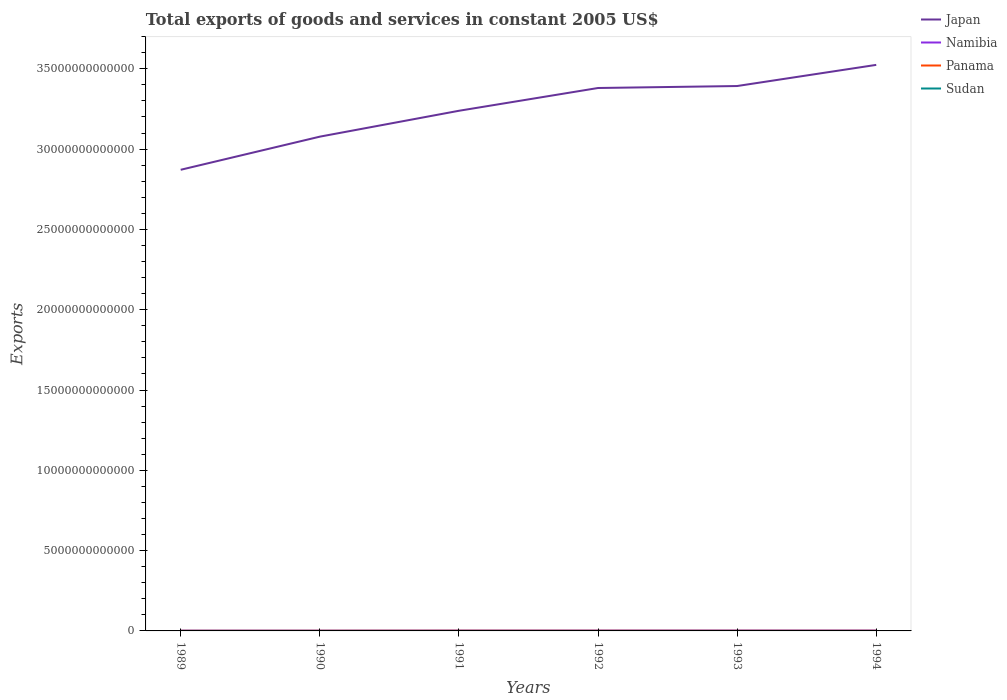Does the line corresponding to Namibia intersect with the line corresponding to Sudan?
Your response must be concise. No. Across all years, what is the maximum total exports of goods and services in Japan?
Give a very brief answer. 2.87e+13. In which year was the total exports of goods and services in Panama maximum?
Your answer should be very brief. 1989. What is the total total exports of goods and services in Sudan in the graph?
Offer a terse response. -1.11e+08. What is the difference between the highest and the second highest total exports of goods and services in Panama?
Offer a terse response. 4.54e+09. Is the total exports of goods and services in Namibia strictly greater than the total exports of goods and services in Panama over the years?
Offer a very short reply. No. How many lines are there?
Keep it short and to the point. 4. How many years are there in the graph?
Ensure brevity in your answer.  6. What is the difference between two consecutive major ticks on the Y-axis?
Make the answer very short. 5.00e+12. How many legend labels are there?
Provide a short and direct response. 4. What is the title of the graph?
Your answer should be compact. Total exports of goods and services in constant 2005 US$. What is the label or title of the X-axis?
Offer a very short reply. Years. What is the label or title of the Y-axis?
Make the answer very short. Exports. What is the Exports in Japan in 1989?
Provide a succinct answer. 2.87e+13. What is the Exports of Namibia in 1989?
Give a very brief answer. 1.60e+1. What is the Exports in Panama in 1989?
Keep it short and to the point. 7.19e+09. What is the Exports of Sudan in 1989?
Offer a terse response. 7.17e+08. What is the Exports in Japan in 1990?
Provide a short and direct response. 3.08e+13. What is the Exports of Namibia in 1990?
Provide a succinct answer. 1.42e+1. What is the Exports in Panama in 1990?
Your response must be concise. 8.42e+09. What is the Exports in Sudan in 1990?
Your answer should be very brief. 5.49e+08. What is the Exports in Japan in 1991?
Make the answer very short. 3.24e+13. What is the Exports in Namibia in 1991?
Give a very brief answer. 1.83e+1. What is the Exports in Panama in 1991?
Ensure brevity in your answer.  1.17e+1. What is the Exports in Sudan in 1991?
Make the answer very short. 5.02e+08. What is the Exports in Japan in 1992?
Ensure brevity in your answer.  3.38e+13. What is the Exports in Namibia in 1992?
Offer a terse response. 1.95e+1. What is the Exports of Panama in 1992?
Ensure brevity in your answer.  1.07e+1. What is the Exports in Sudan in 1992?
Offer a terse response. 6.14e+08. What is the Exports in Japan in 1993?
Provide a short and direct response. 3.39e+13. What is the Exports in Namibia in 1993?
Your answer should be very brief. 2.15e+1. What is the Exports in Panama in 1993?
Keep it short and to the point. 9.63e+09. What is the Exports in Sudan in 1993?
Your answer should be very brief. 5.62e+08. What is the Exports in Japan in 1994?
Your answer should be very brief. 3.52e+13. What is the Exports in Namibia in 1994?
Keep it short and to the point. 2.09e+1. What is the Exports of Panama in 1994?
Give a very brief answer. 9.27e+09. What is the Exports in Sudan in 1994?
Offer a terse response. 6.09e+08. Across all years, what is the maximum Exports in Japan?
Give a very brief answer. 3.52e+13. Across all years, what is the maximum Exports in Namibia?
Provide a short and direct response. 2.15e+1. Across all years, what is the maximum Exports in Panama?
Keep it short and to the point. 1.17e+1. Across all years, what is the maximum Exports in Sudan?
Give a very brief answer. 7.17e+08. Across all years, what is the minimum Exports of Japan?
Offer a very short reply. 2.87e+13. Across all years, what is the minimum Exports in Namibia?
Ensure brevity in your answer.  1.42e+1. Across all years, what is the minimum Exports in Panama?
Offer a terse response. 7.19e+09. Across all years, what is the minimum Exports in Sudan?
Keep it short and to the point. 5.02e+08. What is the total Exports in Japan in the graph?
Provide a succinct answer. 1.95e+14. What is the total Exports of Namibia in the graph?
Keep it short and to the point. 1.10e+11. What is the total Exports of Panama in the graph?
Keep it short and to the point. 5.70e+1. What is the total Exports of Sudan in the graph?
Keep it short and to the point. 3.55e+09. What is the difference between the Exports in Japan in 1989 and that in 1990?
Offer a terse response. -2.06e+12. What is the difference between the Exports of Namibia in 1989 and that in 1990?
Your response must be concise. 1.76e+09. What is the difference between the Exports in Panama in 1989 and that in 1990?
Offer a terse response. -1.23e+09. What is the difference between the Exports of Sudan in 1989 and that in 1990?
Your answer should be very brief. 1.69e+08. What is the difference between the Exports of Japan in 1989 and that in 1991?
Make the answer very short. -3.67e+12. What is the difference between the Exports in Namibia in 1989 and that in 1991?
Provide a short and direct response. -2.33e+09. What is the difference between the Exports of Panama in 1989 and that in 1991?
Make the answer very short. -4.54e+09. What is the difference between the Exports in Sudan in 1989 and that in 1991?
Make the answer very short. 2.15e+08. What is the difference between the Exports in Japan in 1989 and that in 1992?
Ensure brevity in your answer.  -5.09e+12. What is the difference between the Exports in Namibia in 1989 and that in 1992?
Ensure brevity in your answer.  -3.49e+09. What is the difference between the Exports in Panama in 1989 and that in 1992?
Make the answer very short. -3.55e+09. What is the difference between the Exports in Sudan in 1989 and that in 1992?
Provide a short and direct response. 1.04e+08. What is the difference between the Exports in Japan in 1989 and that in 1993?
Your answer should be compact. -5.22e+12. What is the difference between the Exports of Namibia in 1989 and that in 1993?
Give a very brief answer. -5.57e+09. What is the difference between the Exports of Panama in 1989 and that in 1993?
Make the answer very short. -2.44e+09. What is the difference between the Exports of Sudan in 1989 and that in 1993?
Offer a very short reply. 1.55e+08. What is the difference between the Exports of Japan in 1989 and that in 1994?
Give a very brief answer. -6.53e+12. What is the difference between the Exports in Namibia in 1989 and that in 1994?
Make the answer very short. -4.88e+09. What is the difference between the Exports of Panama in 1989 and that in 1994?
Offer a very short reply. -2.08e+09. What is the difference between the Exports in Sudan in 1989 and that in 1994?
Your response must be concise. 1.08e+08. What is the difference between the Exports of Japan in 1990 and that in 1991?
Your answer should be very brief. -1.61e+12. What is the difference between the Exports of Namibia in 1990 and that in 1991?
Provide a succinct answer. -4.10e+09. What is the difference between the Exports in Panama in 1990 and that in 1991?
Your answer should be compact. -3.31e+09. What is the difference between the Exports in Sudan in 1990 and that in 1991?
Make the answer very short. 4.62e+07. What is the difference between the Exports of Japan in 1990 and that in 1992?
Offer a very short reply. -3.03e+12. What is the difference between the Exports of Namibia in 1990 and that in 1992?
Provide a short and direct response. -5.25e+09. What is the difference between the Exports in Panama in 1990 and that in 1992?
Keep it short and to the point. -2.32e+09. What is the difference between the Exports in Sudan in 1990 and that in 1992?
Offer a terse response. -6.51e+07. What is the difference between the Exports of Japan in 1990 and that in 1993?
Your answer should be very brief. -3.15e+12. What is the difference between the Exports of Namibia in 1990 and that in 1993?
Provide a succinct answer. -7.34e+09. What is the difference between the Exports of Panama in 1990 and that in 1993?
Your answer should be compact. -1.21e+09. What is the difference between the Exports in Sudan in 1990 and that in 1993?
Your answer should be compact. -1.31e+07. What is the difference between the Exports of Japan in 1990 and that in 1994?
Give a very brief answer. -4.47e+12. What is the difference between the Exports in Namibia in 1990 and that in 1994?
Offer a very short reply. -6.64e+09. What is the difference between the Exports in Panama in 1990 and that in 1994?
Provide a succinct answer. -8.55e+08. What is the difference between the Exports of Sudan in 1990 and that in 1994?
Make the answer very short. -6.07e+07. What is the difference between the Exports in Japan in 1991 and that in 1992?
Make the answer very short. -1.42e+12. What is the difference between the Exports in Namibia in 1991 and that in 1992?
Your answer should be compact. -1.16e+09. What is the difference between the Exports of Panama in 1991 and that in 1992?
Make the answer very short. 9.91e+08. What is the difference between the Exports in Sudan in 1991 and that in 1992?
Your answer should be compact. -1.11e+08. What is the difference between the Exports of Japan in 1991 and that in 1993?
Provide a short and direct response. -1.54e+12. What is the difference between the Exports of Namibia in 1991 and that in 1993?
Your response must be concise. -3.24e+09. What is the difference between the Exports of Panama in 1991 and that in 1993?
Ensure brevity in your answer.  2.11e+09. What is the difference between the Exports of Sudan in 1991 and that in 1993?
Ensure brevity in your answer.  -5.93e+07. What is the difference between the Exports of Japan in 1991 and that in 1994?
Your answer should be very brief. -2.86e+12. What is the difference between the Exports in Namibia in 1991 and that in 1994?
Provide a short and direct response. -2.55e+09. What is the difference between the Exports of Panama in 1991 and that in 1994?
Your answer should be very brief. 2.46e+09. What is the difference between the Exports of Sudan in 1991 and that in 1994?
Your response must be concise. -1.07e+08. What is the difference between the Exports of Japan in 1992 and that in 1993?
Offer a terse response. -1.23e+11. What is the difference between the Exports of Namibia in 1992 and that in 1993?
Ensure brevity in your answer.  -2.08e+09. What is the difference between the Exports in Panama in 1992 and that in 1993?
Offer a terse response. 1.11e+09. What is the difference between the Exports in Sudan in 1992 and that in 1993?
Your answer should be compact. 5.20e+07. What is the difference between the Exports in Japan in 1992 and that in 1994?
Offer a very short reply. -1.44e+12. What is the difference between the Exports of Namibia in 1992 and that in 1994?
Your answer should be compact. -1.39e+09. What is the difference between the Exports in Panama in 1992 and that in 1994?
Give a very brief answer. 1.47e+09. What is the difference between the Exports of Sudan in 1992 and that in 1994?
Give a very brief answer. 4.40e+06. What is the difference between the Exports of Japan in 1993 and that in 1994?
Your answer should be compact. -1.32e+12. What is the difference between the Exports in Namibia in 1993 and that in 1994?
Provide a succinct answer. 6.95e+08. What is the difference between the Exports in Panama in 1993 and that in 1994?
Your answer should be very brief. 3.54e+08. What is the difference between the Exports in Sudan in 1993 and that in 1994?
Offer a very short reply. -4.76e+07. What is the difference between the Exports of Japan in 1989 and the Exports of Namibia in 1990?
Provide a short and direct response. 2.87e+13. What is the difference between the Exports in Japan in 1989 and the Exports in Panama in 1990?
Keep it short and to the point. 2.87e+13. What is the difference between the Exports of Japan in 1989 and the Exports of Sudan in 1990?
Make the answer very short. 2.87e+13. What is the difference between the Exports of Namibia in 1989 and the Exports of Panama in 1990?
Offer a terse response. 7.56e+09. What is the difference between the Exports in Namibia in 1989 and the Exports in Sudan in 1990?
Keep it short and to the point. 1.54e+1. What is the difference between the Exports in Panama in 1989 and the Exports in Sudan in 1990?
Offer a terse response. 6.64e+09. What is the difference between the Exports of Japan in 1989 and the Exports of Namibia in 1991?
Make the answer very short. 2.87e+13. What is the difference between the Exports in Japan in 1989 and the Exports in Panama in 1991?
Give a very brief answer. 2.87e+13. What is the difference between the Exports of Japan in 1989 and the Exports of Sudan in 1991?
Give a very brief answer. 2.87e+13. What is the difference between the Exports of Namibia in 1989 and the Exports of Panama in 1991?
Offer a very short reply. 4.25e+09. What is the difference between the Exports in Namibia in 1989 and the Exports in Sudan in 1991?
Keep it short and to the point. 1.55e+1. What is the difference between the Exports in Panama in 1989 and the Exports in Sudan in 1991?
Give a very brief answer. 6.69e+09. What is the difference between the Exports of Japan in 1989 and the Exports of Namibia in 1992?
Your answer should be compact. 2.87e+13. What is the difference between the Exports in Japan in 1989 and the Exports in Panama in 1992?
Make the answer very short. 2.87e+13. What is the difference between the Exports of Japan in 1989 and the Exports of Sudan in 1992?
Offer a very short reply. 2.87e+13. What is the difference between the Exports in Namibia in 1989 and the Exports in Panama in 1992?
Make the answer very short. 5.24e+09. What is the difference between the Exports of Namibia in 1989 and the Exports of Sudan in 1992?
Your answer should be compact. 1.54e+1. What is the difference between the Exports of Panama in 1989 and the Exports of Sudan in 1992?
Give a very brief answer. 6.58e+09. What is the difference between the Exports in Japan in 1989 and the Exports in Namibia in 1993?
Ensure brevity in your answer.  2.87e+13. What is the difference between the Exports of Japan in 1989 and the Exports of Panama in 1993?
Make the answer very short. 2.87e+13. What is the difference between the Exports of Japan in 1989 and the Exports of Sudan in 1993?
Make the answer very short. 2.87e+13. What is the difference between the Exports in Namibia in 1989 and the Exports in Panama in 1993?
Provide a succinct answer. 6.35e+09. What is the difference between the Exports in Namibia in 1989 and the Exports in Sudan in 1993?
Your answer should be compact. 1.54e+1. What is the difference between the Exports in Panama in 1989 and the Exports in Sudan in 1993?
Your answer should be very brief. 6.63e+09. What is the difference between the Exports in Japan in 1989 and the Exports in Namibia in 1994?
Give a very brief answer. 2.87e+13. What is the difference between the Exports of Japan in 1989 and the Exports of Panama in 1994?
Keep it short and to the point. 2.87e+13. What is the difference between the Exports of Japan in 1989 and the Exports of Sudan in 1994?
Your response must be concise. 2.87e+13. What is the difference between the Exports in Namibia in 1989 and the Exports in Panama in 1994?
Your answer should be compact. 6.70e+09. What is the difference between the Exports of Namibia in 1989 and the Exports of Sudan in 1994?
Offer a terse response. 1.54e+1. What is the difference between the Exports in Panama in 1989 and the Exports in Sudan in 1994?
Offer a terse response. 6.58e+09. What is the difference between the Exports in Japan in 1990 and the Exports in Namibia in 1991?
Your answer should be compact. 3.08e+13. What is the difference between the Exports of Japan in 1990 and the Exports of Panama in 1991?
Your response must be concise. 3.08e+13. What is the difference between the Exports of Japan in 1990 and the Exports of Sudan in 1991?
Provide a succinct answer. 3.08e+13. What is the difference between the Exports of Namibia in 1990 and the Exports of Panama in 1991?
Your response must be concise. 2.48e+09. What is the difference between the Exports of Namibia in 1990 and the Exports of Sudan in 1991?
Offer a terse response. 1.37e+1. What is the difference between the Exports in Panama in 1990 and the Exports in Sudan in 1991?
Your response must be concise. 7.91e+09. What is the difference between the Exports of Japan in 1990 and the Exports of Namibia in 1992?
Provide a succinct answer. 3.08e+13. What is the difference between the Exports of Japan in 1990 and the Exports of Panama in 1992?
Your answer should be very brief. 3.08e+13. What is the difference between the Exports in Japan in 1990 and the Exports in Sudan in 1992?
Give a very brief answer. 3.08e+13. What is the difference between the Exports in Namibia in 1990 and the Exports in Panama in 1992?
Your response must be concise. 3.47e+09. What is the difference between the Exports in Namibia in 1990 and the Exports in Sudan in 1992?
Provide a succinct answer. 1.36e+1. What is the difference between the Exports of Panama in 1990 and the Exports of Sudan in 1992?
Your response must be concise. 7.80e+09. What is the difference between the Exports in Japan in 1990 and the Exports in Namibia in 1993?
Provide a succinct answer. 3.08e+13. What is the difference between the Exports of Japan in 1990 and the Exports of Panama in 1993?
Your answer should be compact. 3.08e+13. What is the difference between the Exports of Japan in 1990 and the Exports of Sudan in 1993?
Offer a terse response. 3.08e+13. What is the difference between the Exports in Namibia in 1990 and the Exports in Panama in 1993?
Provide a short and direct response. 4.59e+09. What is the difference between the Exports of Namibia in 1990 and the Exports of Sudan in 1993?
Provide a succinct answer. 1.37e+1. What is the difference between the Exports of Panama in 1990 and the Exports of Sudan in 1993?
Keep it short and to the point. 7.86e+09. What is the difference between the Exports of Japan in 1990 and the Exports of Namibia in 1994?
Keep it short and to the point. 3.08e+13. What is the difference between the Exports of Japan in 1990 and the Exports of Panama in 1994?
Provide a succinct answer. 3.08e+13. What is the difference between the Exports of Japan in 1990 and the Exports of Sudan in 1994?
Provide a short and direct response. 3.08e+13. What is the difference between the Exports of Namibia in 1990 and the Exports of Panama in 1994?
Give a very brief answer. 4.94e+09. What is the difference between the Exports in Namibia in 1990 and the Exports in Sudan in 1994?
Ensure brevity in your answer.  1.36e+1. What is the difference between the Exports of Panama in 1990 and the Exports of Sudan in 1994?
Provide a succinct answer. 7.81e+09. What is the difference between the Exports of Japan in 1991 and the Exports of Namibia in 1992?
Your response must be concise. 3.24e+13. What is the difference between the Exports of Japan in 1991 and the Exports of Panama in 1992?
Your response must be concise. 3.24e+13. What is the difference between the Exports in Japan in 1991 and the Exports in Sudan in 1992?
Provide a short and direct response. 3.24e+13. What is the difference between the Exports of Namibia in 1991 and the Exports of Panama in 1992?
Ensure brevity in your answer.  7.57e+09. What is the difference between the Exports of Namibia in 1991 and the Exports of Sudan in 1992?
Ensure brevity in your answer.  1.77e+1. What is the difference between the Exports of Panama in 1991 and the Exports of Sudan in 1992?
Make the answer very short. 1.11e+1. What is the difference between the Exports in Japan in 1991 and the Exports in Namibia in 1993?
Offer a very short reply. 3.24e+13. What is the difference between the Exports of Japan in 1991 and the Exports of Panama in 1993?
Provide a short and direct response. 3.24e+13. What is the difference between the Exports of Japan in 1991 and the Exports of Sudan in 1993?
Provide a succinct answer. 3.24e+13. What is the difference between the Exports of Namibia in 1991 and the Exports of Panama in 1993?
Keep it short and to the point. 8.68e+09. What is the difference between the Exports of Namibia in 1991 and the Exports of Sudan in 1993?
Give a very brief answer. 1.77e+1. What is the difference between the Exports of Panama in 1991 and the Exports of Sudan in 1993?
Keep it short and to the point. 1.12e+1. What is the difference between the Exports of Japan in 1991 and the Exports of Namibia in 1994?
Your answer should be compact. 3.24e+13. What is the difference between the Exports in Japan in 1991 and the Exports in Panama in 1994?
Offer a very short reply. 3.24e+13. What is the difference between the Exports in Japan in 1991 and the Exports in Sudan in 1994?
Offer a terse response. 3.24e+13. What is the difference between the Exports of Namibia in 1991 and the Exports of Panama in 1994?
Offer a terse response. 9.04e+09. What is the difference between the Exports of Namibia in 1991 and the Exports of Sudan in 1994?
Your answer should be very brief. 1.77e+1. What is the difference between the Exports of Panama in 1991 and the Exports of Sudan in 1994?
Your answer should be compact. 1.11e+1. What is the difference between the Exports of Japan in 1992 and the Exports of Namibia in 1993?
Make the answer very short. 3.38e+13. What is the difference between the Exports in Japan in 1992 and the Exports in Panama in 1993?
Provide a succinct answer. 3.38e+13. What is the difference between the Exports of Japan in 1992 and the Exports of Sudan in 1993?
Your answer should be very brief. 3.38e+13. What is the difference between the Exports in Namibia in 1992 and the Exports in Panama in 1993?
Give a very brief answer. 9.84e+09. What is the difference between the Exports of Namibia in 1992 and the Exports of Sudan in 1993?
Your answer should be compact. 1.89e+1. What is the difference between the Exports in Panama in 1992 and the Exports in Sudan in 1993?
Provide a short and direct response. 1.02e+1. What is the difference between the Exports in Japan in 1992 and the Exports in Namibia in 1994?
Offer a terse response. 3.38e+13. What is the difference between the Exports in Japan in 1992 and the Exports in Panama in 1994?
Make the answer very short. 3.38e+13. What is the difference between the Exports of Japan in 1992 and the Exports of Sudan in 1994?
Your answer should be compact. 3.38e+13. What is the difference between the Exports of Namibia in 1992 and the Exports of Panama in 1994?
Offer a terse response. 1.02e+1. What is the difference between the Exports in Namibia in 1992 and the Exports in Sudan in 1994?
Ensure brevity in your answer.  1.89e+1. What is the difference between the Exports in Panama in 1992 and the Exports in Sudan in 1994?
Provide a succinct answer. 1.01e+1. What is the difference between the Exports in Japan in 1993 and the Exports in Namibia in 1994?
Provide a succinct answer. 3.39e+13. What is the difference between the Exports of Japan in 1993 and the Exports of Panama in 1994?
Provide a short and direct response. 3.39e+13. What is the difference between the Exports in Japan in 1993 and the Exports in Sudan in 1994?
Provide a succinct answer. 3.39e+13. What is the difference between the Exports in Namibia in 1993 and the Exports in Panama in 1994?
Your answer should be compact. 1.23e+1. What is the difference between the Exports in Namibia in 1993 and the Exports in Sudan in 1994?
Keep it short and to the point. 2.09e+1. What is the difference between the Exports of Panama in 1993 and the Exports of Sudan in 1994?
Offer a terse response. 9.02e+09. What is the average Exports in Japan per year?
Your answer should be compact. 3.25e+13. What is the average Exports of Namibia per year?
Your answer should be very brief. 1.84e+1. What is the average Exports of Panama per year?
Give a very brief answer. 9.50e+09. What is the average Exports of Sudan per year?
Offer a terse response. 5.92e+08. In the year 1989, what is the difference between the Exports of Japan and Exports of Namibia?
Provide a succinct answer. 2.87e+13. In the year 1989, what is the difference between the Exports of Japan and Exports of Panama?
Your response must be concise. 2.87e+13. In the year 1989, what is the difference between the Exports in Japan and Exports in Sudan?
Your answer should be compact. 2.87e+13. In the year 1989, what is the difference between the Exports in Namibia and Exports in Panama?
Your answer should be compact. 8.79e+09. In the year 1989, what is the difference between the Exports in Namibia and Exports in Sudan?
Your response must be concise. 1.53e+1. In the year 1989, what is the difference between the Exports of Panama and Exports of Sudan?
Provide a succinct answer. 6.47e+09. In the year 1990, what is the difference between the Exports of Japan and Exports of Namibia?
Give a very brief answer. 3.08e+13. In the year 1990, what is the difference between the Exports of Japan and Exports of Panama?
Provide a short and direct response. 3.08e+13. In the year 1990, what is the difference between the Exports in Japan and Exports in Sudan?
Provide a succinct answer. 3.08e+13. In the year 1990, what is the difference between the Exports of Namibia and Exports of Panama?
Your response must be concise. 5.80e+09. In the year 1990, what is the difference between the Exports of Namibia and Exports of Sudan?
Offer a very short reply. 1.37e+1. In the year 1990, what is the difference between the Exports of Panama and Exports of Sudan?
Your response must be concise. 7.87e+09. In the year 1991, what is the difference between the Exports of Japan and Exports of Namibia?
Your response must be concise. 3.24e+13. In the year 1991, what is the difference between the Exports of Japan and Exports of Panama?
Ensure brevity in your answer.  3.24e+13. In the year 1991, what is the difference between the Exports in Japan and Exports in Sudan?
Ensure brevity in your answer.  3.24e+13. In the year 1991, what is the difference between the Exports in Namibia and Exports in Panama?
Provide a succinct answer. 6.58e+09. In the year 1991, what is the difference between the Exports of Namibia and Exports of Sudan?
Your answer should be very brief. 1.78e+1. In the year 1991, what is the difference between the Exports of Panama and Exports of Sudan?
Offer a very short reply. 1.12e+1. In the year 1992, what is the difference between the Exports of Japan and Exports of Namibia?
Keep it short and to the point. 3.38e+13. In the year 1992, what is the difference between the Exports of Japan and Exports of Panama?
Ensure brevity in your answer.  3.38e+13. In the year 1992, what is the difference between the Exports in Japan and Exports in Sudan?
Give a very brief answer. 3.38e+13. In the year 1992, what is the difference between the Exports in Namibia and Exports in Panama?
Offer a terse response. 8.73e+09. In the year 1992, what is the difference between the Exports in Namibia and Exports in Sudan?
Offer a terse response. 1.89e+1. In the year 1992, what is the difference between the Exports of Panama and Exports of Sudan?
Make the answer very short. 1.01e+1. In the year 1993, what is the difference between the Exports of Japan and Exports of Namibia?
Your response must be concise. 3.39e+13. In the year 1993, what is the difference between the Exports in Japan and Exports in Panama?
Your answer should be very brief. 3.39e+13. In the year 1993, what is the difference between the Exports in Japan and Exports in Sudan?
Offer a very short reply. 3.39e+13. In the year 1993, what is the difference between the Exports in Namibia and Exports in Panama?
Offer a very short reply. 1.19e+1. In the year 1993, what is the difference between the Exports of Namibia and Exports of Sudan?
Make the answer very short. 2.10e+1. In the year 1993, what is the difference between the Exports in Panama and Exports in Sudan?
Offer a very short reply. 9.06e+09. In the year 1994, what is the difference between the Exports in Japan and Exports in Namibia?
Your answer should be very brief. 3.52e+13. In the year 1994, what is the difference between the Exports in Japan and Exports in Panama?
Offer a very short reply. 3.52e+13. In the year 1994, what is the difference between the Exports of Japan and Exports of Sudan?
Provide a succinct answer. 3.52e+13. In the year 1994, what is the difference between the Exports in Namibia and Exports in Panama?
Offer a terse response. 1.16e+1. In the year 1994, what is the difference between the Exports of Namibia and Exports of Sudan?
Offer a very short reply. 2.02e+1. In the year 1994, what is the difference between the Exports of Panama and Exports of Sudan?
Your answer should be compact. 8.66e+09. What is the ratio of the Exports of Japan in 1989 to that in 1990?
Offer a very short reply. 0.93. What is the ratio of the Exports in Namibia in 1989 to that in 1990?
Give a very brief answer. 1.12. What is the ratio of the Exports of Panama in 1989 to that in 1990?
Keep it short and to the point. 0.85. What is the ratio of the Exports of Sudan in 1989 to that in 1990?
Offer a very short reply. 1.31. What is the ratio of the Exports of Japan in 1989 to that in 1991?
Give a very brief answer. 0.89. What is the ratio of the Exports of Namibia in 1989 to that in 1991?
Your answer should be compact. 0.87. What is the ratio of the Exports in Panama in 1989 to that in 1991?
Provide a short and direct response. 0.61. What is the ratio of the Exports of Sudan in 1989 to that in 1991?
Give a very brief answer. 1.43. What is the ratio of the Exports in Japan in 1989 to that in 1992?
Make the answer very short. 0.85. What is the ratio of the Exports of Namibia in 1989 to that in 1992?
Give a very brief answer. 0.82. What is the ratio of the Exports of Panama in 1989 to that in 1992?
Make the answer very short. 0.67. What is the ratio of the Exports of Sudan in 1989 to that in 1992?
Provide a succinct answer. 1.17. What is the ratio of the Exports in Japan in 1989 to that in 1993?
Offer a terse response. 0.85. What is the ratio of the Exports in Namibia in 1989 to that in 1993?
Offer a terse response. 0.74. What is the ratio of the Exports of Panama in 1989 to that in 1993?
Offer a very short reply. 0.75. What is the ratio of the Exports of Sudan in 1989 to that in 1993?
Provide a short and direct response. 1.28. What is the ratio of the Exports in Japan in 1989 to that in 1994?
Offer a terse response. 0.81. What is the ratio of the Exports of Namibia in 1989 to that in 1994?
Keep it short and to the point. 0.77. What is the ratio of the Exports in Panama in 1989 to that in 1994?
Ensure brevity in your answer.  0.78. What is the ratio of the Exports of Sudan in 1989 to that in 1994?
Make the answer very short. 1.18. What is the ratio of the Exports of Japan in 1990 to that in 1991?
Keep it short and to the point. 0.95. What is the ratio of the Exports in Namibia in 1990 to that in 1991?
Provide a succinct answer. 0.78. What is the ratio of the Exports of Panama in 1990 to that in 1991?
Offer a terse response. 0.72. What is the ratio of the Exports of Sudan in 1990 to that in 1991?
Your answer should be compact. 1.09. What is the ratio of the Exports in Japan in 1990 to that in 1992?
Your answer should be compact. 0.91. What is the ratio of the Exports of Namibia in 1990 to that in 1992?
Make the answer very short. 0.73. What is the ratio of the Exports of Panama in 1990 to that in 1992?
Provide a short and direct response. 0.78. What is the ratio of the Exports of Sudan in 1990 to that in 1992?
Provide a short and direct response. 0.89. What is the ratio of the Exports of Japan in 1990 to that in 1993?
Ensure brevity in your answer.  0.91. What is the ratio of the Exports of Namibia in 1990 to that in 1993?
Your answer should be very brief. 0.66. What is the ratio of the Exports in Panama in 1990 to that in 1993?
Ensure brevity in your answer.  0.87. What is the ratio of the Exports in Sudan in 1990 to that in 1993?
Make the answer very short. 0.98. What is the ratio of the Exports of Japan in 1990 to that in 1994?
Your answer should be compact. 0.87. What is the ratio of the Exports of Namibia in 1990 to that in 1994?
Provide a succinct answer. 0.68. What is the ratio of the Exports in Panama in 1990 to that in 1994?
Give a very brief answer. 0.91. What is the ratio of the Exports in Sudan in 1990 to that in 1994?
Your response must be concise. 0.9. What is the ratio of the Exports in Japan in 1991 to that in 1992?
Ensure brevity in your answer.  0.96. What is the ratio of the Exports in Namibia in 1991 to that in 1992?
Ensure brevity in your answer.  0.94. What is the ratio of the Exports in Panama in 1991 to that in 1992?
Your answer should be very brief. 1.09. What is the ratio of the Exports in Sudan in 1991 to that in 1992?
Keep it short and to the point. 0.82. What is the ratio of the Exports of Japan in 1991 to that in 1993?
Offer a terse response. 0.95. What is the ratio of the Exports in Namibia in 1991 to that in 1993?
Offer a terse response. 0.85. What is the ratio of the Exports of Panama in 1991 to that in 1993?
Provide a succinct answer. 1.22. What is the ratio of the Exports in Sudan in 1991 to that in 1993?
Your answer should be compact. 0.89. What is the ratio of the Exports of Japan in 1991 to that in 1994?
Offer a very short reply. 0.92. What is the ratio of the Exports in Namibia in 1991 to that in 1994?
Your answer should be very brief. 0.88. What is the ratio of the Exports of Panama in 1991 to that in 1994?
Ensure brevity in your answer.  1.27. What is the ratio of the Exports in Sudan in 1991 to that in 1994?
Offer a very short reply. 0.82. What is the ratio of the Exports of Japan in 1992 to that in 1993?
Your answer should be compact. 1. What is the ratio of the Exports of Namibia in 1992 to that in 1993?
Give a very brief answer. 0.9. What is the ratio of the Exports of Panama in 1992 to that in 1993?
Provide a succinct answer. 1.12. What is the ratio of the Exports of Sudan in 1992 to that in 1993?
Make the answer very short. 1.09. What is the ratio of the Exports of Japan in 1992 to that in 1994?
Give a very brief answer. 0.96. What is the ratio of the Exports in Namibia in 1992 to that in 1994?
Give a very brief answer. 0.93. What is the ratio of the Exports of Panama in 1992 to that in 1994?
Offer a terse response. 1.16. What is the ratio of the Exports in Sudan in 1992 to that in 1994?
Offer a terse response. 1.01. What is the ratio of the Exports in Japan in 1993 to that in 1994?
Keep it short and to the point. 0.96. What is the ratio of the Exports of Namibia in 1993 to that in 1994?
Your response must be concise. 1.03. What is the ratio of the Exports of Panama in 1993 to that in 1994?
Your response must be concise. 1.04. What is the ratio of the Exports of Sudan in 1993 to that in 1994?
Offer a terse response. 0.92. What is the difference between the highest and the second highest Exports in Japan?
Your answer should be compact. 1.32e+12. What is the difference between the highest and the second highest Exports of Namibia?
Offer a terse response. 6.95e+08. What is the difference between the highest and the second highest Exports of Panama?
Make the answer very short. 9.91e+08. What is the difference between the highest and the second highest Exports in Sudan?
Your answer should be compact. 1.04e+08. What is the difference between the highest and the lowest Exports of Japan?
Keep it short and to the point. 6.53e+12. What is the difference between the highest and the lowest Exports of Namibia?
Keep it short and to the point. 7.34e+09. What is the difference between the highest and the lowest Exports in Panama?
Keep it short and to the point. 4.54e+09. What is the difference between the highest and the lowest Exports in Sudan?
Ensure brevity in your answer.  2.15e+08. 